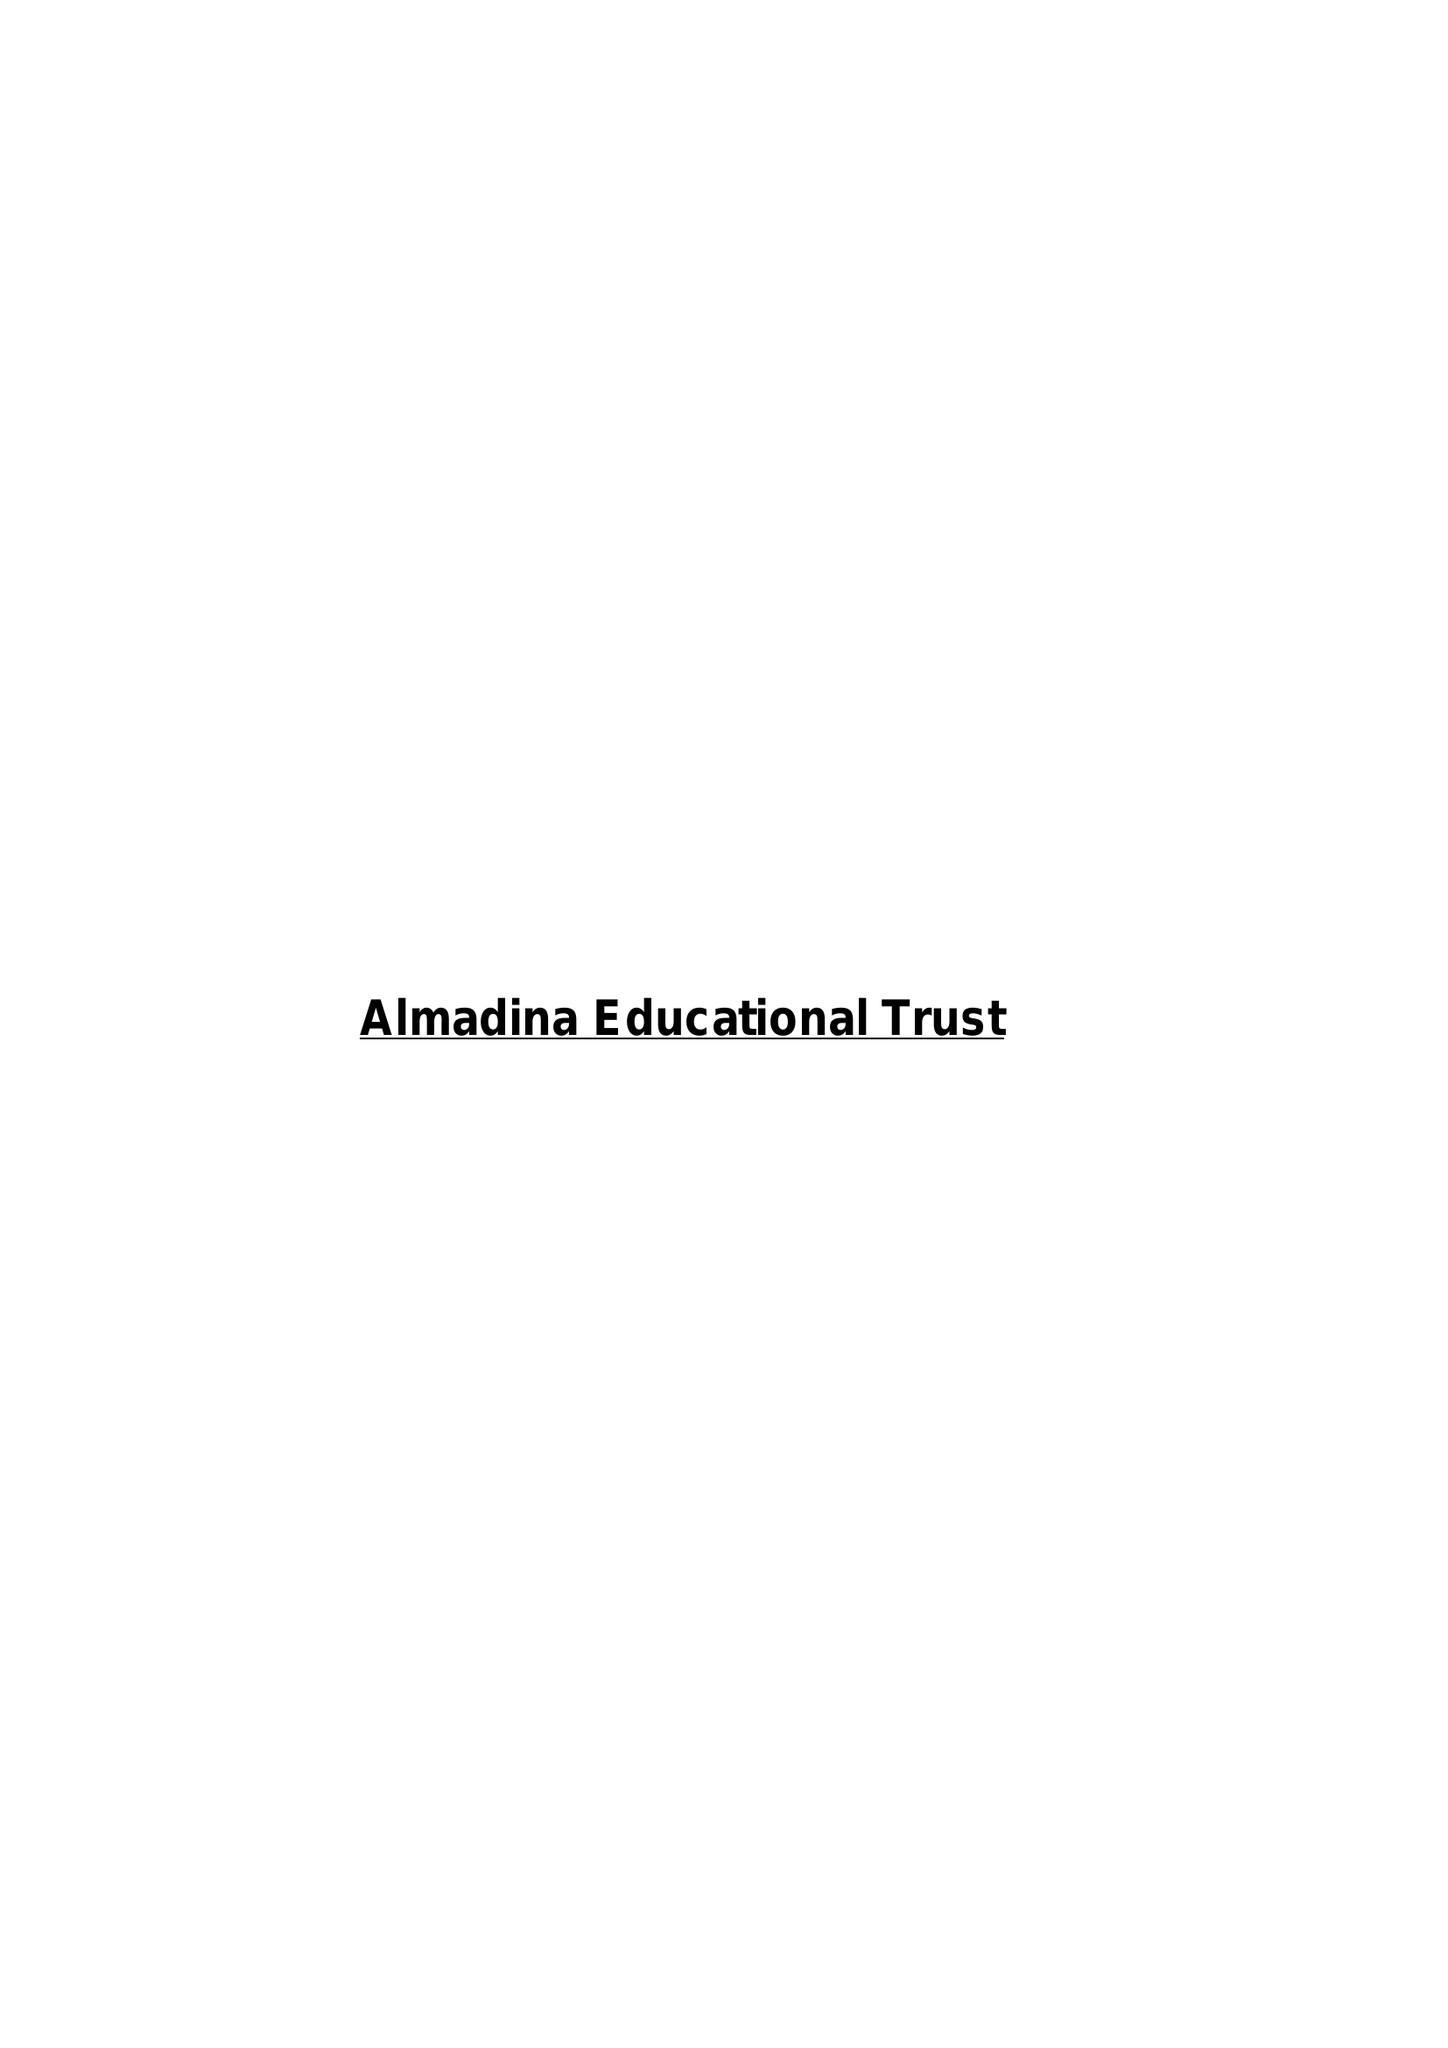What is the value for the charity_number?
Answer the question using a single word or phrase. 1146614 